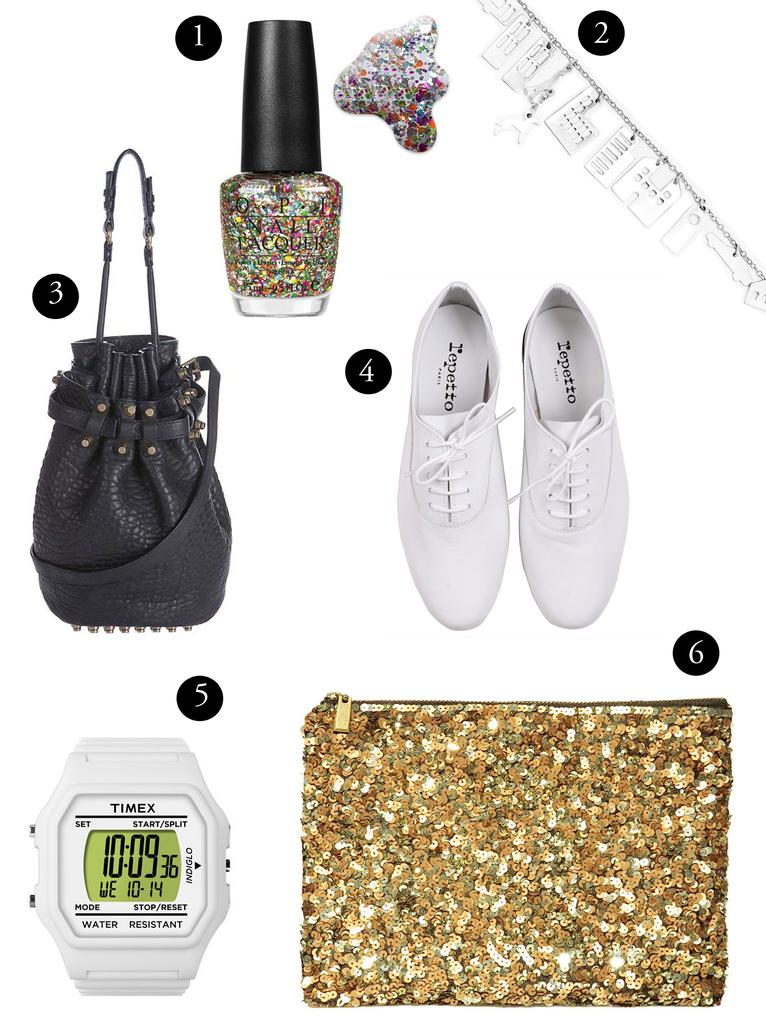<image>
Present a compact description of the photo's key features. Several accessories are numbered fro 1 to 6, including #5 which is a white Timex watch which is water resistant and has Indiglo. 